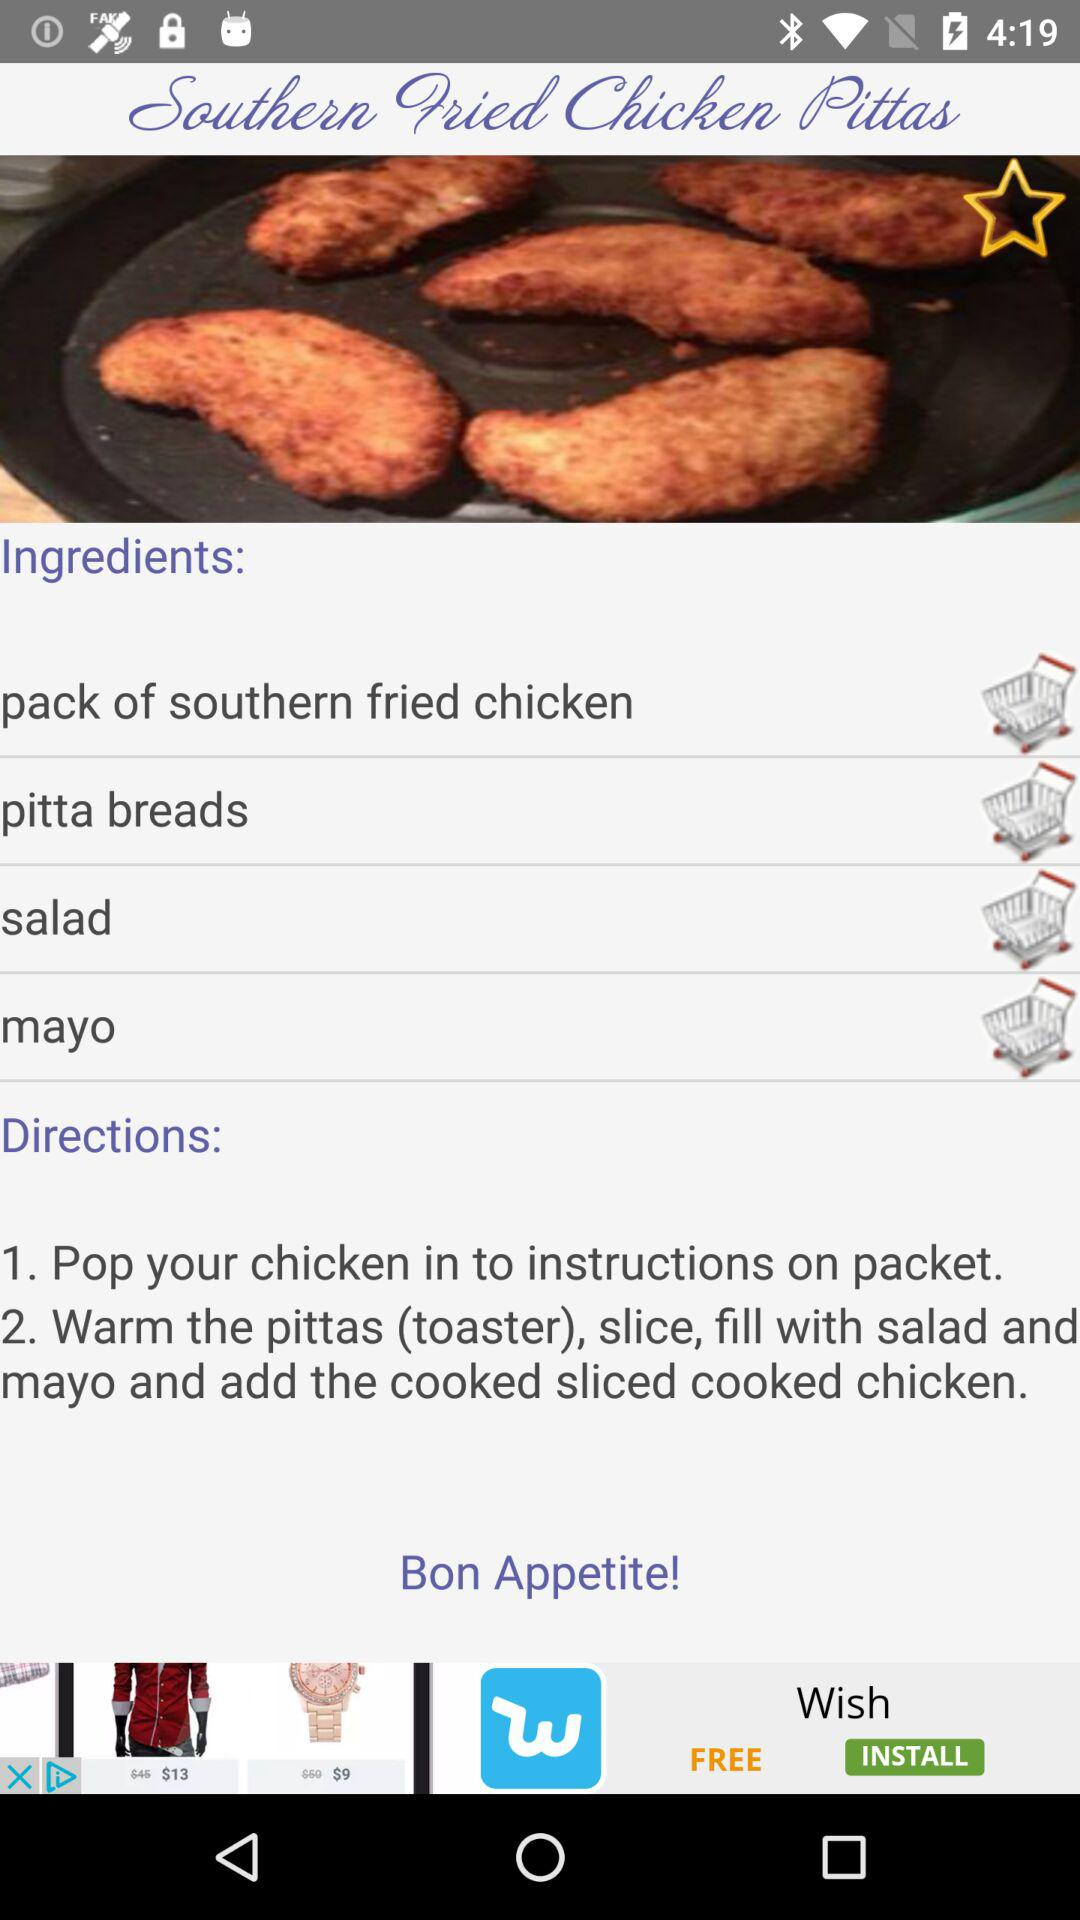How many ingredients are required for this recipe?
Answer the question using a single word or phrase. 4 